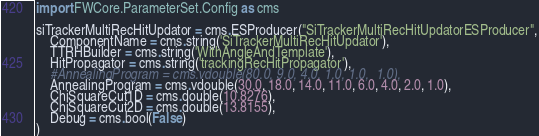Convert code to text. <code><loc_0><loc_0><loc_500><loc_500><_Python_>import FWCore.ParameterSet.Config as cms

siTrackerMultiRecHitUpdator = cms.ESProducer("SiTrackerMultiRecHitUpdatorESProducer",
    ComponentName = cms.string('SiTrackerMultiRecHitUpdator'),
    TTRHBuilder = cms.string('WithAngleAndTemplate'),
    HitPropagator = cms.string('trackingRecHitPropagator'),
    #AnnealingProgram = cms.vdouble(80.0, 9.0, 4.0, 1.0, 1.0,  1.0),
    AnnealingProgram = cms.vdouble(30.0, 18.0, 14.0, 11.0, 6.0, 4.0, 2.0, 1.0),
    ChiSquareCut1D = cms.double(10.8276),
    ChiSquareCut2D = cms.double(13.8155),
    Debug = cms.bool(False)
)


</code> 